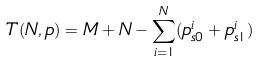<formula> <loc_0><loc_0><loc_500><loc_500>T ( N , p ) = M + N - \sum _ { i = 1 } ^ { N } ( p ^ { i } _ { s 0 } + p ^ { i } _ { s 1 } )</formula> 